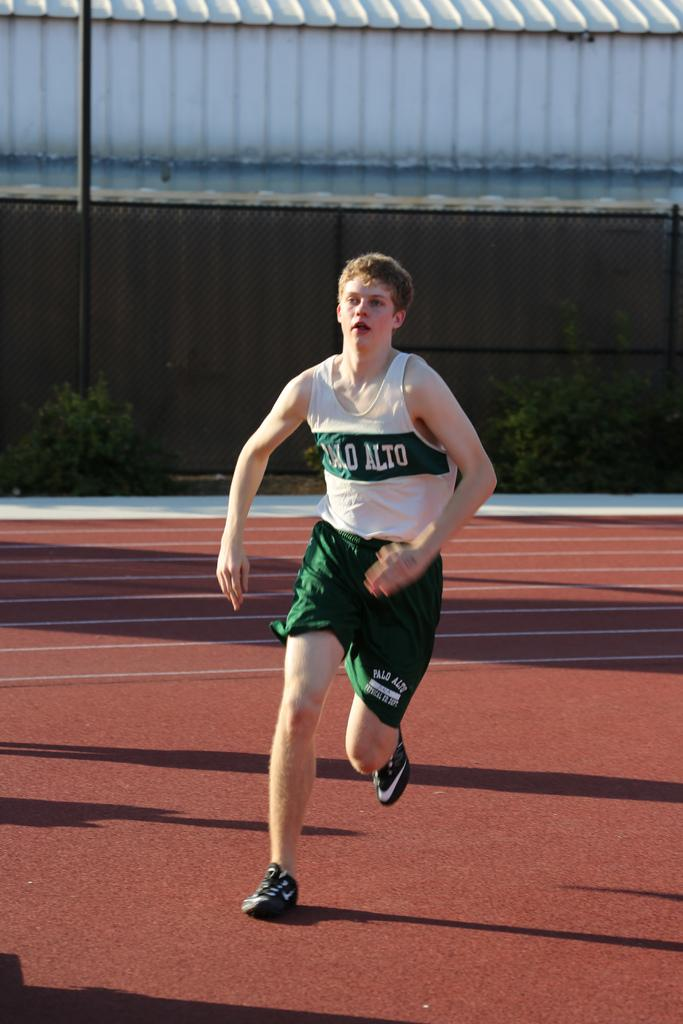<image>
Write a terse but informative summary of the picture. A racer for Palo Alto runs down the track quickly 